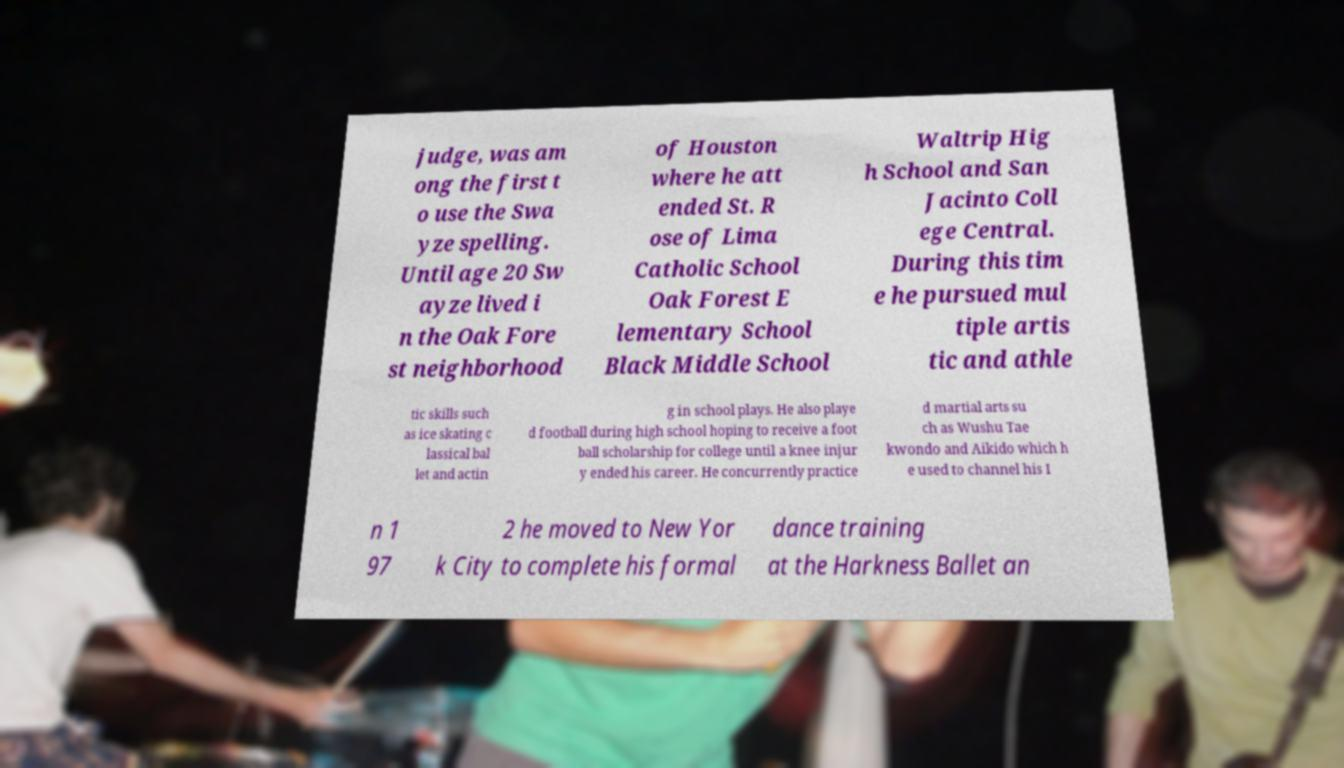Can you accurately transcribe the text from the provided image for me? judge, was am ong the first t o use the Swa yze spelling. Until age 20 Sw ayze lived i n the Oak Fore st neighborhood of Houston where he att ended St. R ose of Lima Catholic School Oak Forest E lementary School Black Middle School Waltrip Hig h School and San Jacinto Coll ege Central. During this tim e he pursued mul tiple artis tic and athle tic skills such as ice skating c lassical bal let and actin g in school plays. He also playe d football during high school hoping to receive a foot ball scholarship for college until a knee injur y ended his career. He concurrently practice d martial arts su ch as Wushu Tae kwondo and Aikido which h e used to channel his I n 1 97 2 he moved to New Yor k City to complete his formal dance training at the Harkness Ballet an 